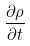<formula> <loc_0><loc_0><loc_500><loc_500>\frac { \partial \rho } { \partial t }</formula> 